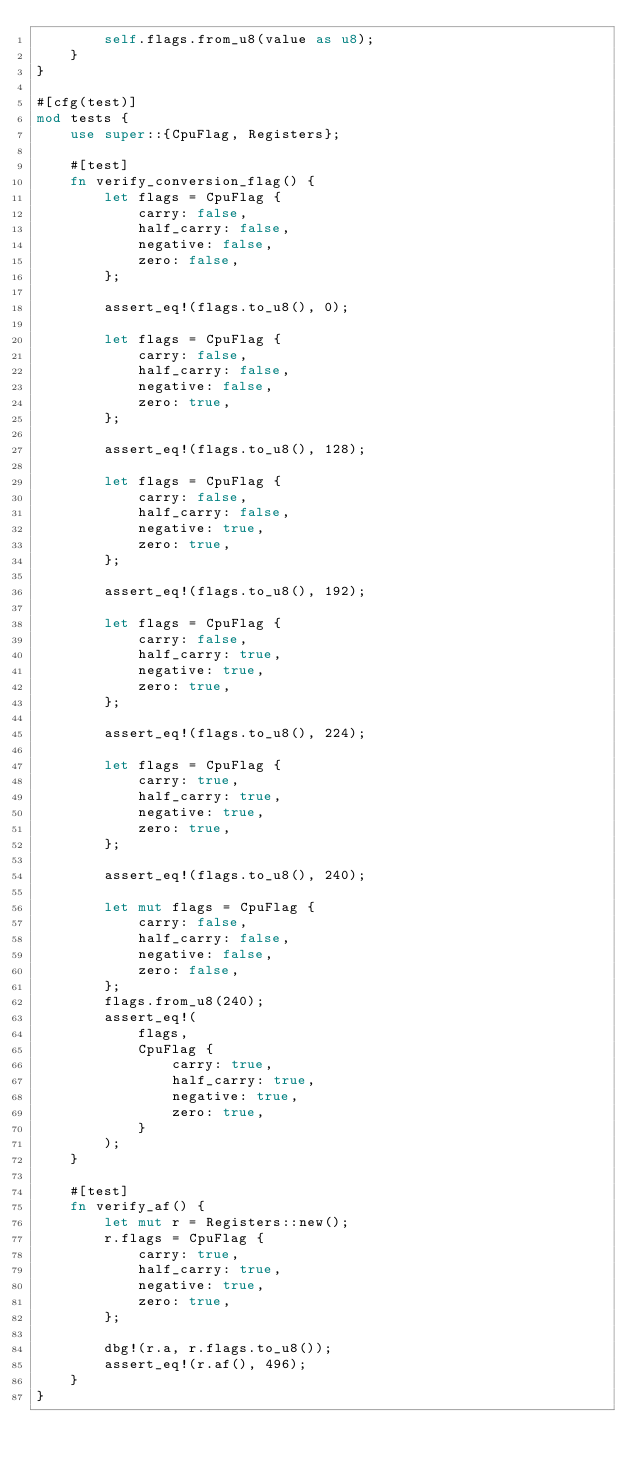Convert code to text. <code><loc_0><loc_0><loc_500><loc_500><_Rust_>        self.flags.from_u8(value as u8);
    }
}

#[cfg(test)]
mod tests {
    use super::{CpuFlag, Registers};

    #[test]
    fn verify_conversion_flag() {
        let flags = CpuFlag {
            carry: false,
            half_carry: false,
            negative: false,
            zero: false,
        };

        assert_eq!(flags.to_u8(), 0);

        let flags = CpuFlag {
            carry: false,
            half_carry: false,
            negative: false,
            zero: true,
        };

        assert_eq!(flags.to_u8(), 128);

        let flags = CpuFlag {
            carry: false,
            half_carry: false,
            negative: true,
            zero: true,
        };

        assert_eq!(flags.to_u8(), 192);

        let flags = CpuFlag {
            carry: false,
            half_carry: true,
            negative: true,
            zero: true,
        };

        assert_eq!(flags.to_u8(), 224);

        let flags = CpuFlag {
            carry: true,
            half_carry: true,
            negative: true,
            zero: true,
        };

        assert_eq!(flags.to_u8(), 240);

        let mut flags = CpuFlag {
            carry: false,
            half_carry: false,
            negative: false,
            zero: false,
        };
        flags.from_u8(240);
        assert_eq!(
            flags,
            CpuFlag {
                carry: true,
                half_carry: true,
                negative: true,
                zero: true,
            }
        );
    }

    #[test]
    fn verify_af() {
        let mut r = Registers::new();
        r.flags = CpuFlag {
            carry: true,
            half_carry: true,
            negative: true,
            zero: true,
        };

        dbg!(r.a, r.flags.to_u8());
        assert_eq!(r.af(), 496);
    }
}
</code> 